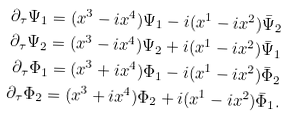<formula> <loc_0><loc_0><loc_500><loc_500>\partial _ { \tau } \Psi _ { 1 } = ( x ^ { 3 } - i x ^ { 4 } ) \Psi _ { 1 } - i ( x ^ { 1 } - i x ^ { 2 } ) \bar { \Psi } _ { 2 } \\ \partial _ { \tau } \Psi _ { 2 } = ( x ^ { 3 } - i x ^ { 4 } ) \Psi _ { 2 } + i ( x ^ { 1 } - i x ^ { 2 } ) \bar { \Psi } _ { 1 } \\ \partial _ { \tau } \Phi _ { 1 } = ( x ^ { 3 } + i x ^ { 4 } ) \Phi _ { 1 } - i ( x ^ { 1 } - i x ^ { 2 } ) \bar { \Phi } _ { 2 } \\ \partial _ { \tau } \Phi _ { 2 } = ( x ^ { 3 } + i x ^ { 4 } ) \Phi _ { 2 } + i ( x ^ { 1 } - i x ^ { 2 } ) \bar { \Phi } _ { 1 } .</formula> 